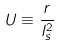<formula> <loc_0><loc_0><loc_500><loc_500>U \equiv \frac { r } { l _ { s } ^ { 2 } }</formula> 